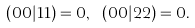Convert formula to latex. <formula><loc_0><loc_0><loc_500><loc_500>( 0 0 | 1 1 ) = 0 , \ ( 0 0 | 2 2 ) = 0 .</formula> 